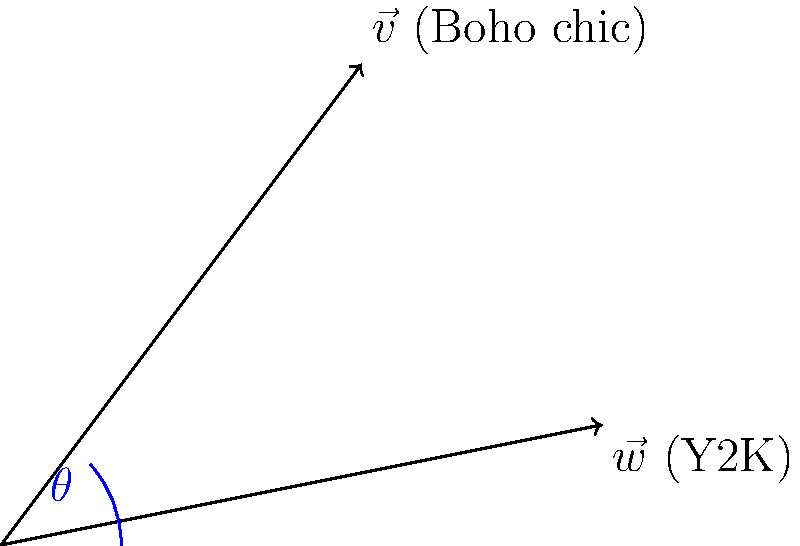Aubrey Riley's fashion style often combines elements of Boho chic and Y2K aesthetics. If we represent these styles as vectors $\vec{v}$ (Boho chic) and $\vec{w}$ (Y2K) respectively, what is the angle $\theta$ between them? Use the given coordinates: $\vec{v} = (3,4)$ and $\vec{w} = (5,1)$. To find the angle between two vectors, we can use the dot product formula:

1) The dot product formula: $\cos \theta = \frac{\vec{v} \cdot \vec{w}}{|\vec{v}||\vec{w}|}$

2) Calculate the dot product:
   $\vec{v} \cdot \vec{w} = (3)(5) + (4)(1) = 15 + 4 = 19$

3) Calculate the magnitudes:
   $|\vec{v}| = \sqrt{3^2 + 4^2} = \sqrt{25} = 5$
   $|\vec{w}| = \sqrt{5^2 + 1^2} = \sqrt{26}$

4) Substitute into the formula:
   $\cos \theta = \frac{19}{5\sqrt{26}}$

5) Take the inverse cosine (arccos) of both sides:
   $\theta = \arccos(\frac{19}{5\sqrt{26}})$

6) Calculate the result:
   $\theta \approx 0.5095$ radians

7) Convert to degrees:
   $\theta \approx 29.21°$
Answer: $29.21°$ 